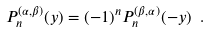Convert formula to latex. <formula><loc_0><loc_0><loc_500><loc_500>P ^ { ( \alpha , \beta ) } _ { n } ( y ) = ( - 1 ) ^ { n } P ^ { ( \beta , \alpha ) } _ { n } ( - y ) \ .</formula> 